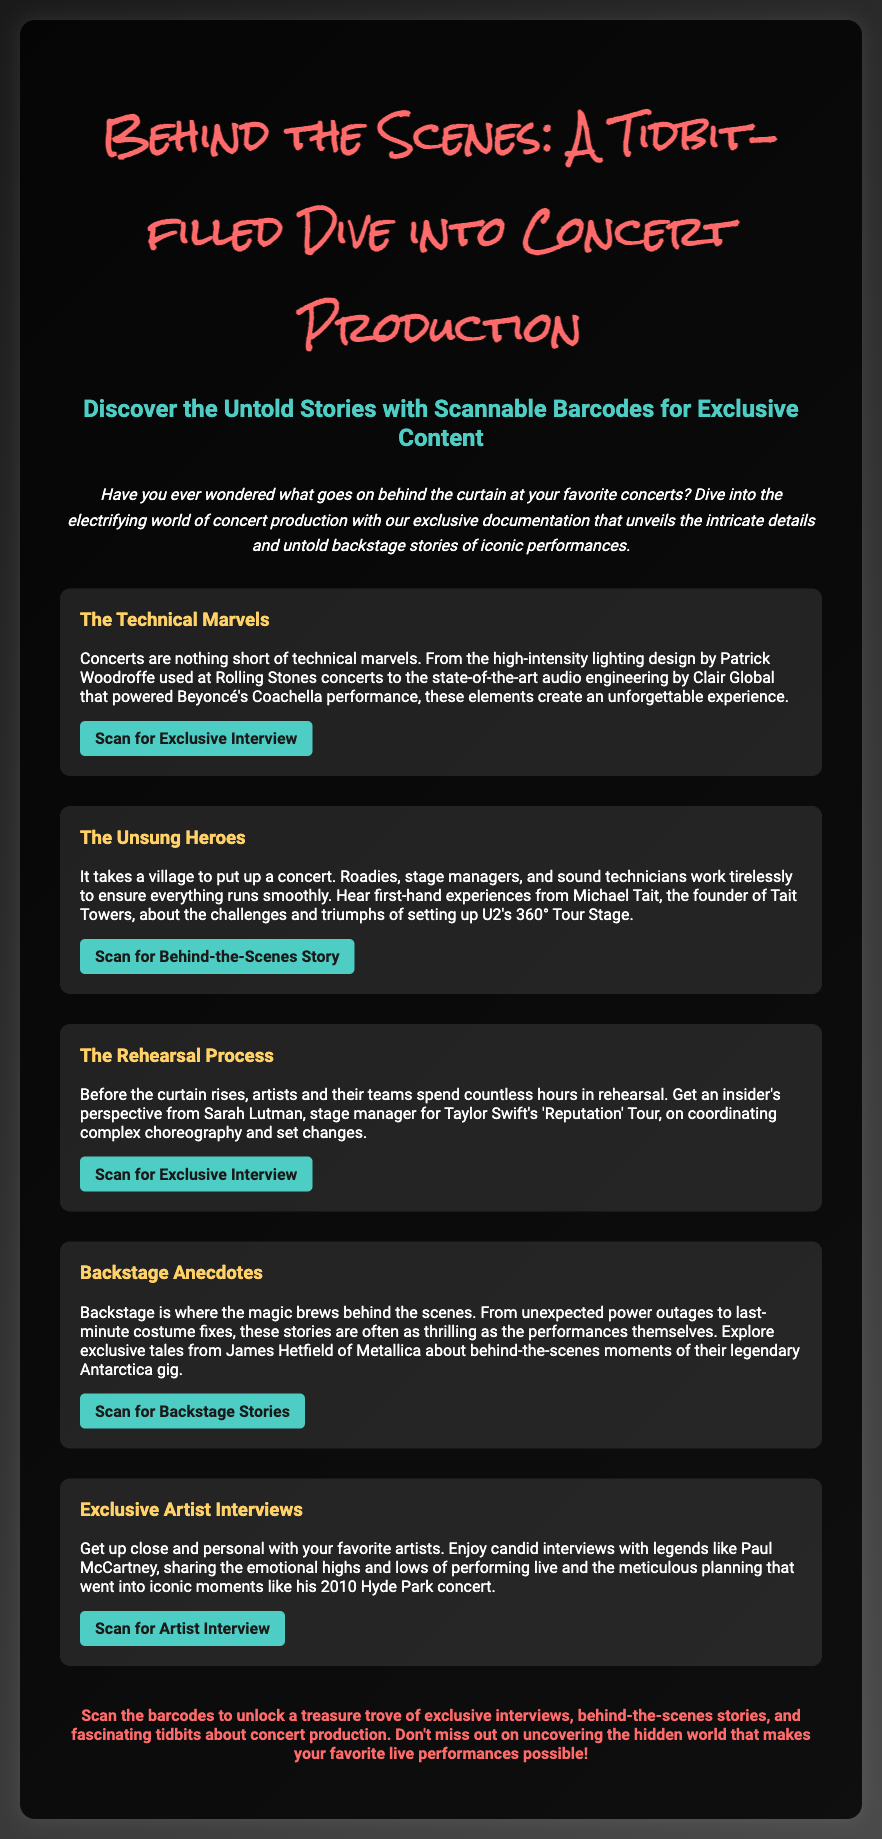What is the main topic of the flyer? The flyer focuses on concert production and behind-the-scenes stories.
Answer: Concert Production Who is the lighting designer mentioned in the document? The document mentions Patrick Woodroffe as the lighting designer for Rolling Stones concerts.
Answer: Patrick Woodroffe Which artist's 'Reputation' Tour is discussed? The document discusses the rehearsal process for Taylor Swift's 'Reputation' Tour.
Answer: Taylor Swift What type of content can you access by scanning the barcodes? Scanning the barcodes allows access to exclusive interviews and backstage stories.
Answer: Exclusive interviews and backstage stories Who founded Tait Towers? The document attributes the founding of Tait Towers to Michael Tait.
Answer: Michael Tait What is the color of the section headers in the flyer? The section headers are colored in a specific bright shade mentioned in the document.
Answer: #ffd166 What type of experiences are shared by James Hetfield? The document indicates that he shares backstage anecdotes related to Metallica's performances.
Answer: Backstage anecdotes What is the main call to action in the flyer? The main call to action encourages readers to scan barcodes for access to exclusive content.
Answer: Scan the barcodes What year did Paul McCartney perform at Hyde Park? The document notes Paul McCartney's iconic performance took place in 2010.
Answer: 2010 